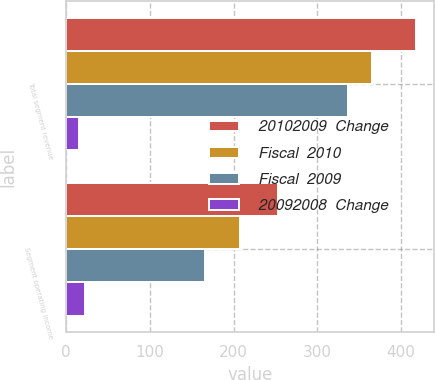Convert chart to OTSL. <chart><loc_0><loc_0><loc_500><loc_500><stacked_bar_chart><ecel><fcel>Total segment revenue<fcel>Segment operating income<nl><fcel>20102009  Change<fcel>418<fcel>253<nl><fcel>Fiscal  2010<fcel>365<fcel>208<nl><fcel>Fiscal  2009<fcel>337<fcel>166<nl><fcel>20092008  Change<fcel>15<fcel>22<nl></chart> 